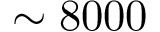<formula> <loc_0><loc_0><loc_500><loc_500>\sim 8 0 0 0</formula> 